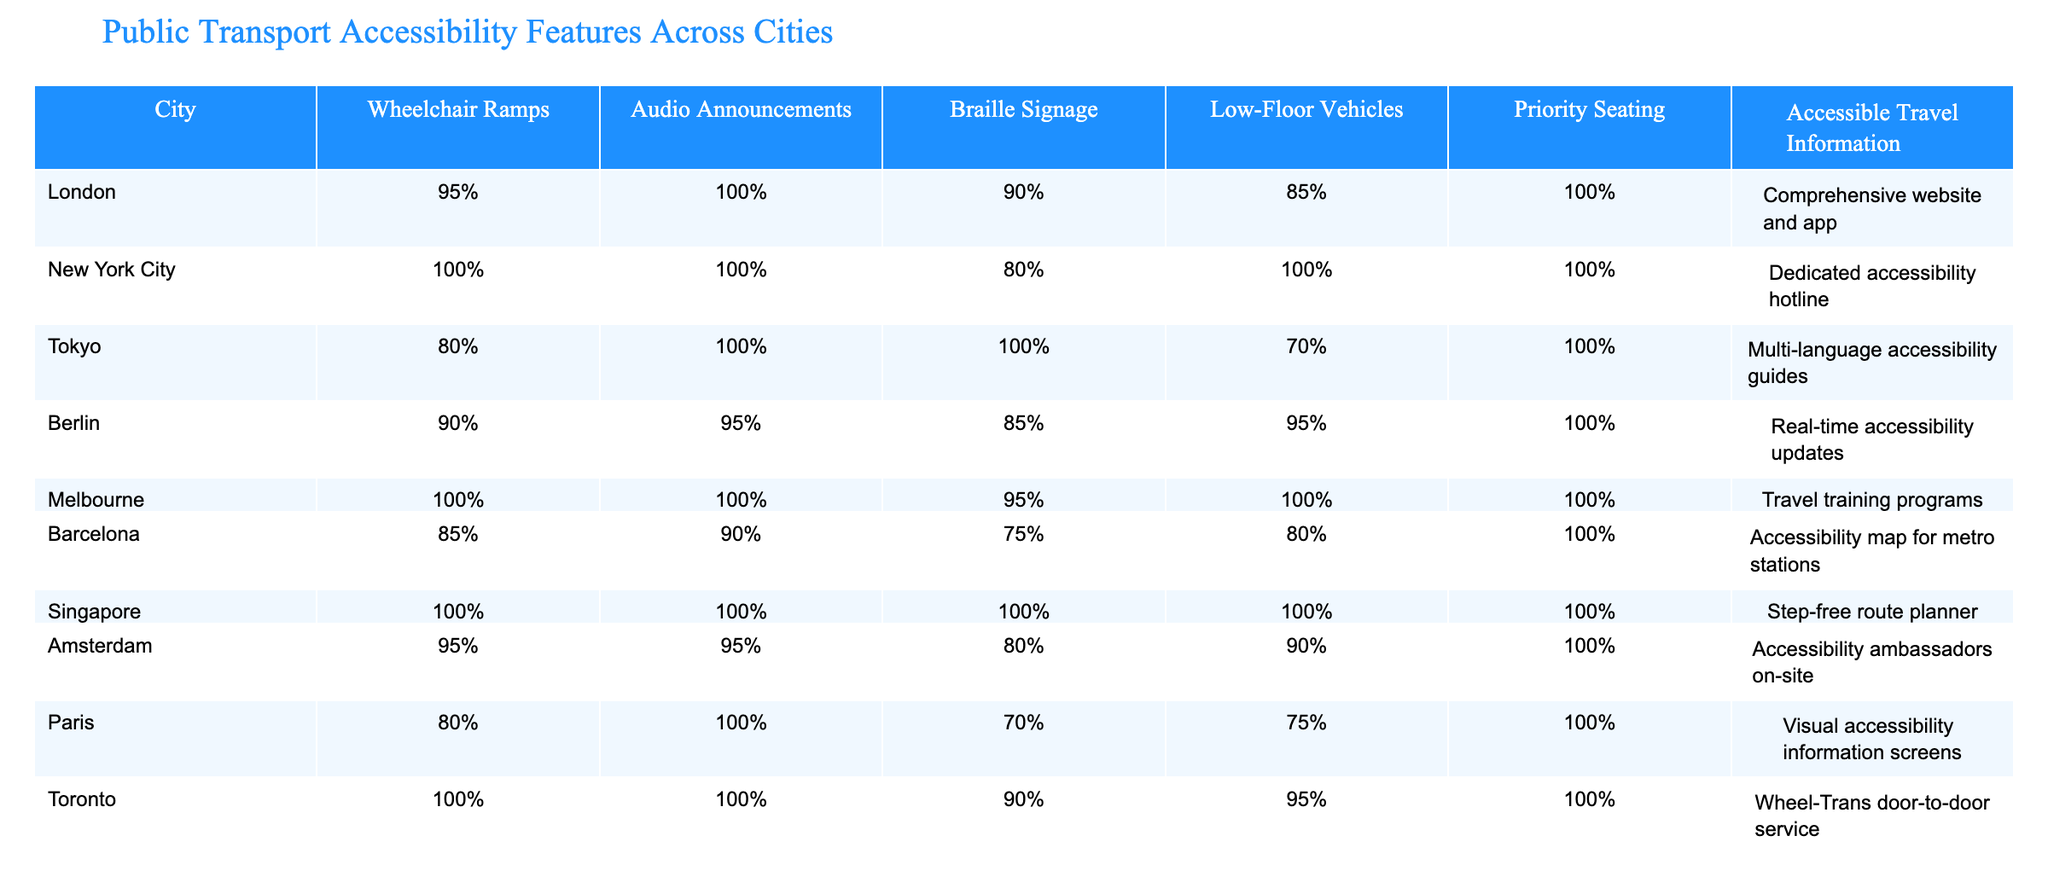What percentage of cities provide wheelchair ramps? The table shows that all cities except Tokyo, Barcelona, and Berlin provide wheelchair ramps at 80% or higher. The only cities with less than 90% are Tokyo (80%), Barcelona (85%), and Berlin (90%). Since all other cities have 90% or more, we see that 7 out of 10 cities have at least 90% wheelchair ramp accessibility.
Answer: 70% Which city has the highest percentage of low-floor vehicles? Looking at the column for low-floor vehicles, both New York City and Melbourne have the highest value at 100%. Therefore, these two cities have the best provision for low-floor vehicles in public transport.
Answer: New York City and Melbourne Is there any city that has 100% accessibility features across the board? By examining the table, we can see that Singapore is the only city that has 100% across all listed accessibility features: wheelchair ramps, audio announcements, braille signage, low-floor vehicles, priority seating, and accessible travel information.
Answer: Yes What is the average percentage of accessible travel information across all cities? To find the average, we collect the accessible travel information percentages: London (Comprehensive website and app), New York City (Dedicated accessibility hotline), Tokyo (Multi-language accessibility guides), Berlin (Real-time accessibility updates), Melbourne (Travel training programs), Barcelona (Accessibility map for metro stations), Singapore (Step-free route planner), Amsterdam (Accessibility ambassadors on-site), Paris (Visual accessibility information screens), Toronto (Wheel-Trans door-to-door service). Since we cannot quantify these descriptions, we are unable to calculate a numerical average. Hence the average cannot be determined purely from the data available here.
Answer: Not applicable Which city has the lowest percentage of braille signage? Observing the braille signage percentages, we can see that Barcelona has the lowest value at 75%. Therefore, this city has the least provision for braille signage among the cities listed.
Answer: Barcelona 